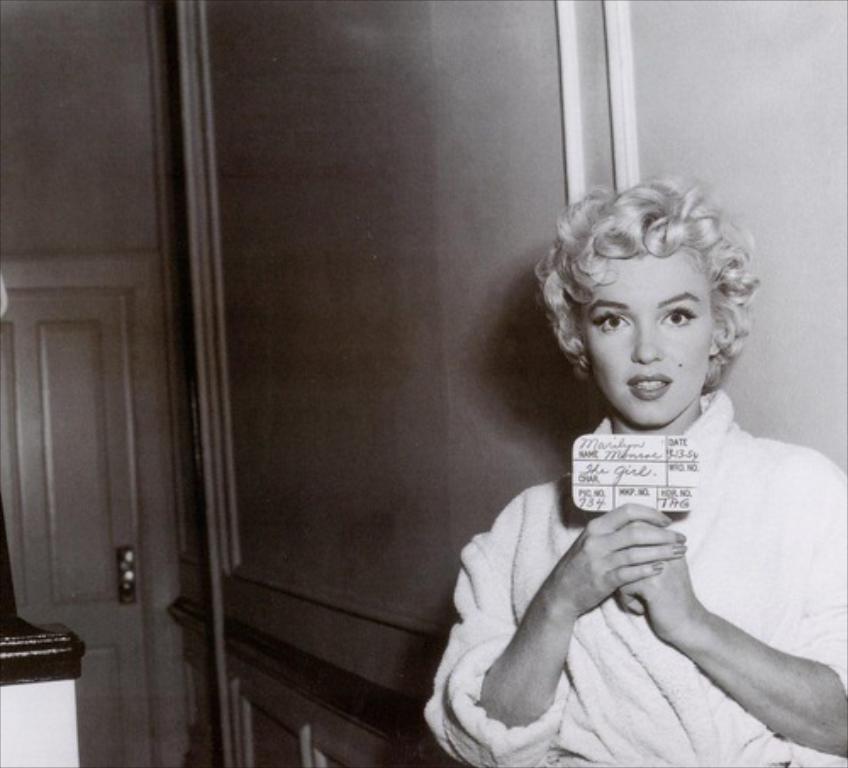In one or two sentences, can you explain what this image depicts? In this image we can see a person standing and holding a board with text and numbers. In the background, we can see the wall with door and rods. 